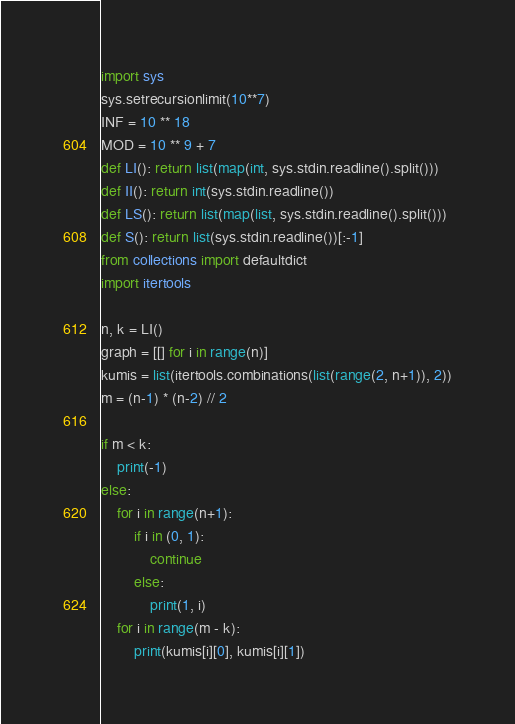<code> <loc_0><loc_0><loc_500><loc_500><_Python_>import sys
sys.setrecursionlimit(10**7)
INF = 10 ** 18
MOD = 10 ** 9 + 7
def LI(): return list(map(int, sys.stdin.readline().split()))
def II(): return int(sys.stdin.readline())
def LS(): return list(map(list, sys.stdin.readline().split()))
def S(): return list(sys.stdin.readline())[:-1]
from collections import defaultdict
import itertools

n, k = LI()
graph = [[] for i in range(n)]
kumis = list(itertools.combinations(list(range(2, n+1)), 2))
m = (n-1) * (n-2) // 2

if m < k:
    print(-1)
else:
    for i in range(n+1):
        if i in (0, 1):
            continue
        else:
            print(1, i)
    for i in range(m - k):
        print(kumis[i][0], kumis[i][1])</code> 